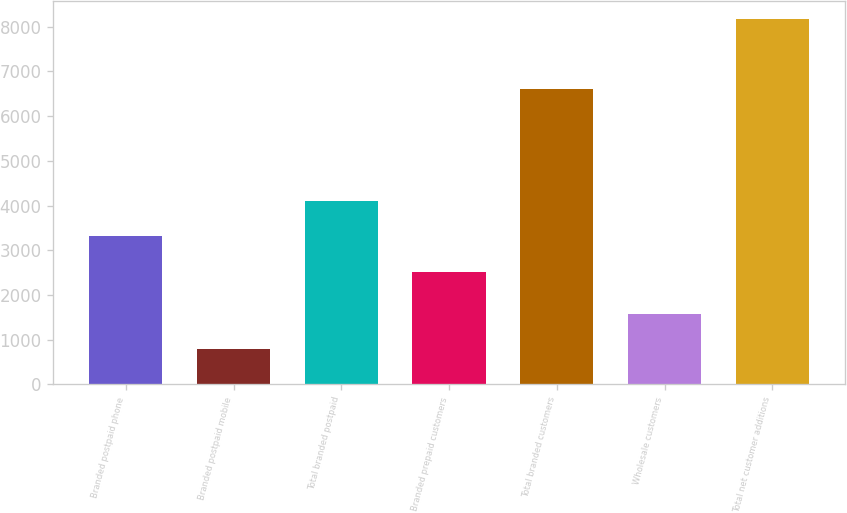Convert chart. <chart><loc_0><loc_0><loc_500><loc_500><bar_chart><fcel>Branded postpaid phone<fcel>Branded postpaid mobile<fcel>Total branded postpaid<fcel>Branded prepaid customers<fcel>Total branded customers<fcel>Wholesale customers<fcel>Total net customer additions<nl><fcel>3307<fcel>790<fcel>4097<fcel>2508<fcel>6605<fcel>1568<fcel>8173<nl></chart> 